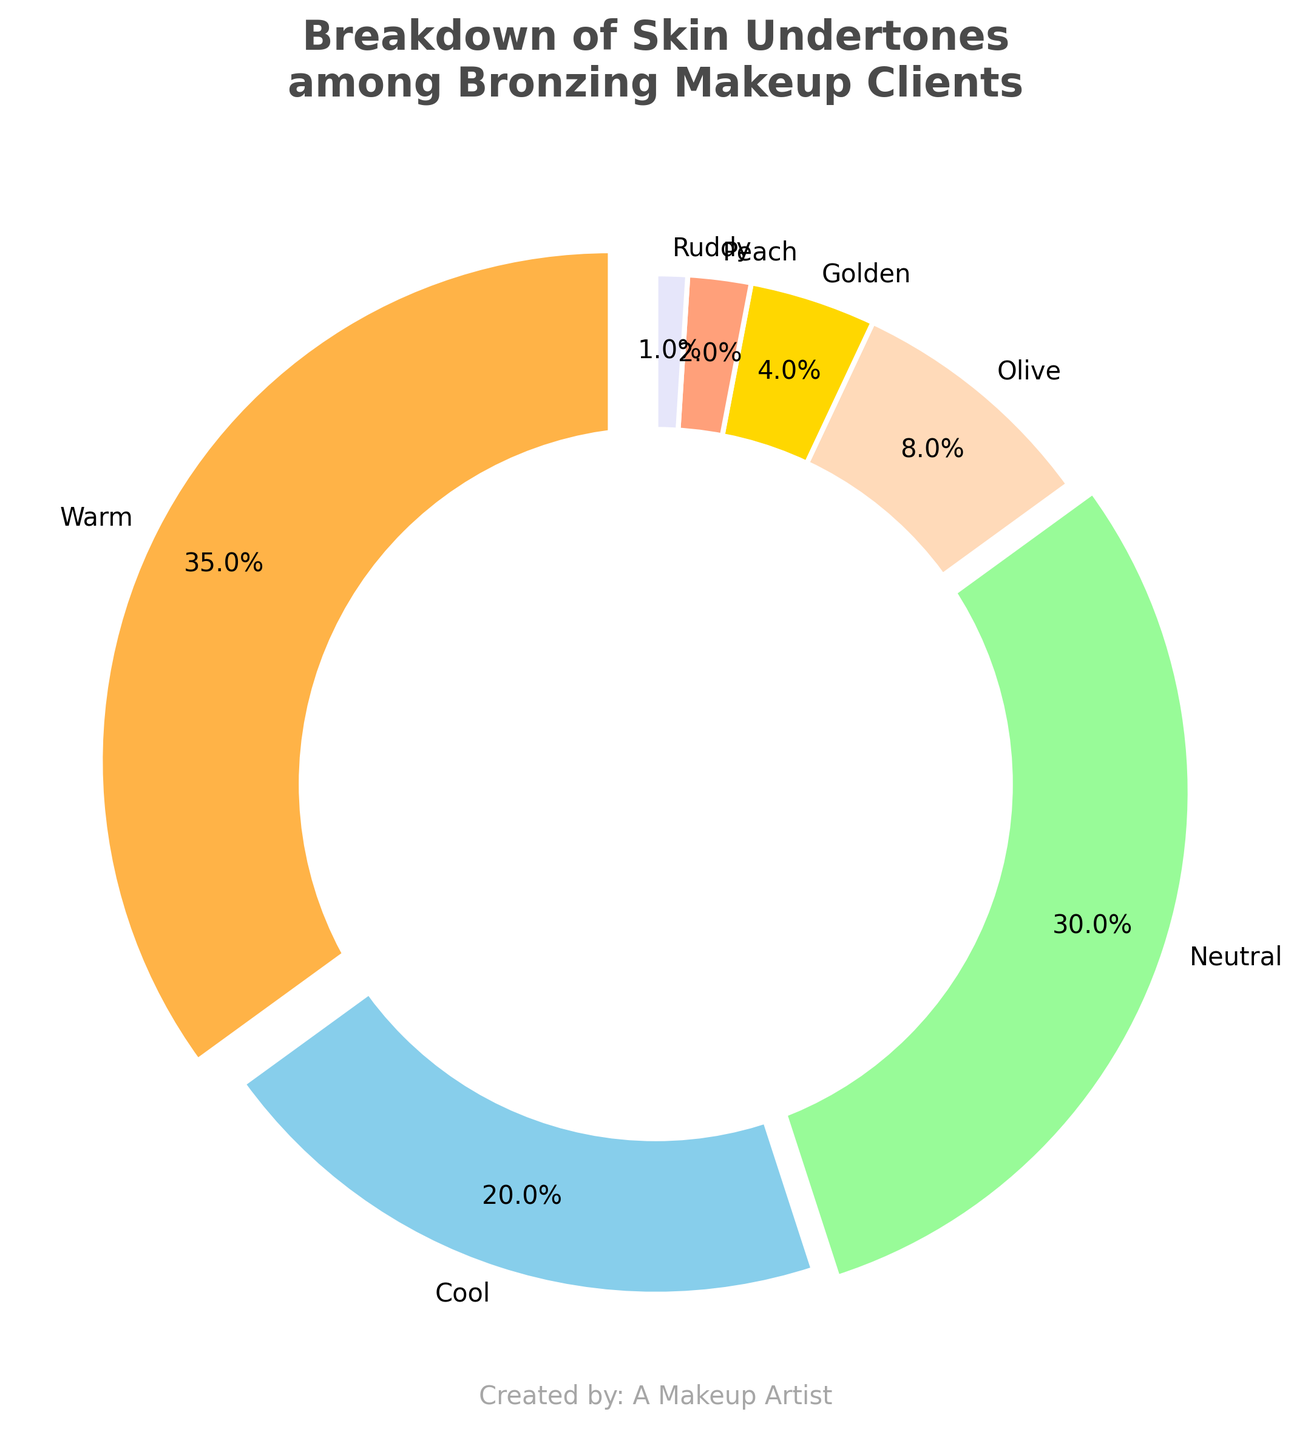What's the most common skin undertone among bronzing makeup clients? The pie chart shows that "Warm" has the largest portion, taking up 35% of the chart.
Answer: Warm Which skin undertone is the least common among bronzing makeup clients? The pie chart shows that "Ruddy" occupies only a small slice, representing 1% of the total.
Answer: Ruddy What is the combined percentage of clients with neutral and cool undertones? Add the percentages for Neutral (30%) and Cool (20%): 30% + 20% = 50%.
Answer: 50% Are there more clients with olive or golden undertones? The pie chart shows Olive with 8% and Golden with 4%, so Olive has a larger percentage.
Answer: Olive What percentage of clients have either peach or ruddy undertones? Add the percentages for Peach (2%) and Ruddy (1%): 2% + 1% = 3%.
Answer: 3% What is the difference in percentage between clients with warm and cool undertones? Subtract the percentage of Cool (20%) from Warm (35%): 35% - 20% = 15%.
Answer: 15% Which undertone is represented by a darker color, Olive or Golden? Visually, Olive is represented by a darker color compared to Golden in the pie chart.
Answer: Olive Are neutral or warm undertones closer in percentage to olive undertones? Neutral is 30%, Warm is 35%, and Olive is 8%. Neutral (30% - 8% = 22%) is closer to Olive than Warm (35% - 8% = 27%).
Answer: Neutral Which three undertones combined make up less than 15% of the total clients? Add the percentages for the smallest three undertones: Peach (2%), Ruddy (1%), and Golden (4%): 2% + 1% + 4% = 7%.
Answer: Peach, Ruddy, Golden What is the total percentage of clients with either warm, cool, or neutral undertones? Add the percentages for Warm (35%), Cool (20%), and Neutral (30%): 35% + 20% + 30% = 85%.
Answer: 85% 